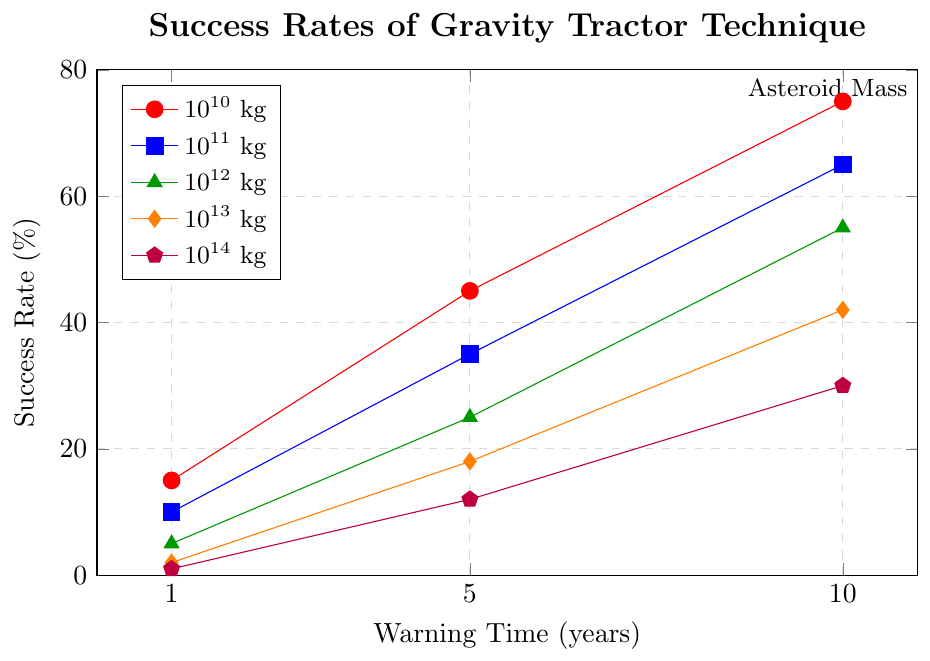What is the success rate for an asteroid with a mass of $10^{12}$ kg when the warning time is 5 years? To find the success rate for an asteroid with a mass of $10^{12}$ kg and a warning time of 5 years, look for the green line at the x-value of 5 years. The corresponding y-value is 25%.
Answer: 25% How does the success rate change for a $10^{11}$ kg asteroid from 1 year to 10 years? Observe the blue line representing the $10^{11}$ kg asteroid. At 1 year, the success rate is 10%. At 10 years, the success rate is 65%. Subtract the former from the latter (65% - 10% = 55%) to find the change.
Answer: 55% Which asteroid mass reaches the highest success rate with a 10-year warning time? Check the y-values for all lines at the 10-year mark. The red line, representing $10^{10}$ kg, reaches the highest value at 75%.
Answer: $10^{10}$ kg What is the difference in success rates between a $10^{13}$ kg asteroid and a $10^{14}$ kg asteroid at 5 years of warning time? Look at the orange and purple lines at the 5-year mark. The success rate for $10^{13}$ kg (orange) is 18%, and for $10^{14}$ kg (purple) it is 12%. The difference is 18% - 12% = 6%.
Answer: 6% For which asteroid mass does the success rate not exceed 30%? Identify the lines and their maximum y-values. The purple line, representing $10^{14}$ kg, does not exceed 30%.
Answer: $10^{14}$ kg How much higher is the success rate for a $10^{10}$ kg asteroid compared to a $10^{13}$ kg asteroid with a 1-year warning? Examine the red and orange lines at the 1-year warning mark. The red line ($10^{10}$ kg) is at 15%, and the orange line ($10^{13}$ kg) is at 2%. The difference is 15% - 2% = 13%.
Answer: 13% What is the increase in success rate for a $10^{12}$ kg asteroid when the warning time changes from 1 year to 5 years, and then from 5 years to 10 years? For a $10^{12}$ kg asteroid (green), the success rate goes from 5% at 1 year to 25% at 5 years, an increase of 25% - 5% = 20%. From 5 years to 10 years, it increases from 25% to 55%, which is a change of 55% - 25% = 30%.
Answer: 20% and 30% Which mass of asteroid shows the steepest increase in success rate between 1 and 5 years of warning time? Compare the slopes of the lines from 1 to 5 years. The red line ($10^{10}$ kg) goes from 15% to 45%, a difference of 30%. The blue line ($10^{11}$ kg) goes from 10% to 35%, a difference of 25%. Continue comparing the other lines in this way.
Answer: $10^{10}$ kg 